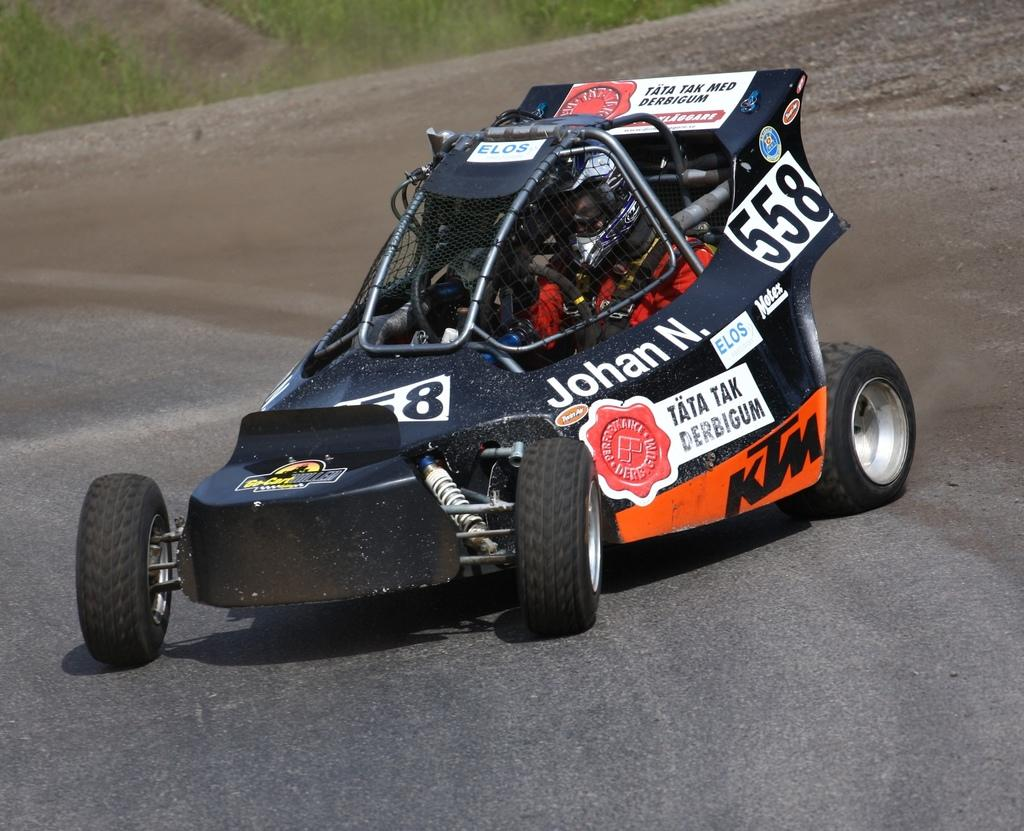What type of vehicle is in the image? There is a sports car in the image. What color is the sports car? The sports car is black in color. What is at the bottom of the image? There is a road at the bottom of the image. What can be seen in the background of the image? There is green grass visible in the background of the image. What time does the clock on the sports car show in the image? There is no clock present on the sports car in the image. 